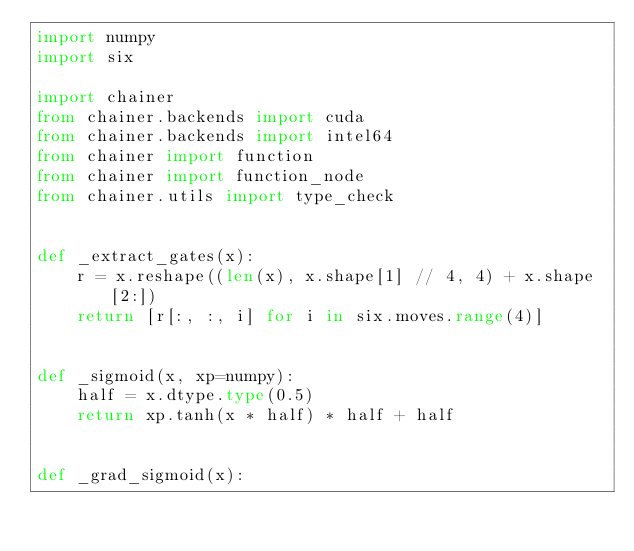Convert code to text. <code><loc_0><loc_0><loc_500><loc_500><_Python_>import numpy
import six

import chainer
from chainer.backends import cuda
from chainer.backends import intel64
from chainer import function
from chainer import function_node
from chainer.utils import type_check


def _extract_gates(x):
    r = x.reshape((len(x), x.shape[1] // 4, 4) + x.shape[2:])
    return [r[:, :, i] for i in six.moves.range(4)]


def _sigmoid(x, xp=numpy):
    half = x.dtype.type(0.5)
    return xp.tanh(x * half) * half + half


def _grad_sigmoid(x):</code> 